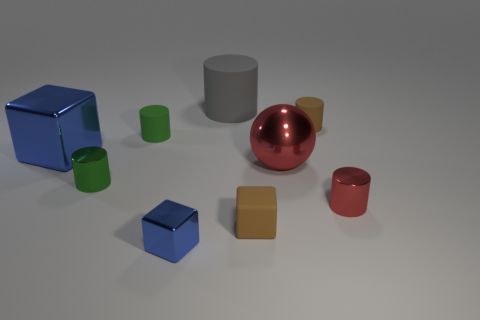Subtract all tiny blue blocks. How many blocks are left? 2 Subtract all brown blocks. How many blocks are left? 2 Subtract all cylinders. How many objects are left? 4 Subtract all cyan spheres. Subtract all yellow cylinders. How many spheres are left? 1 Subtract all red cubes. How many brown cylinders are left? 1 Subtract all cubes. Subtract all green metallic cylinders. How many objects are left? 5 Add 7 gray matte cylinders. How many gray matte cylinders are left? 8 Add 9 yellow blocks. How many yellow blocks exist? 9 Add 1 cyan objects. How many objects exist? 10 Subtract 0 yellow cylinders. How many objects are left? 9 